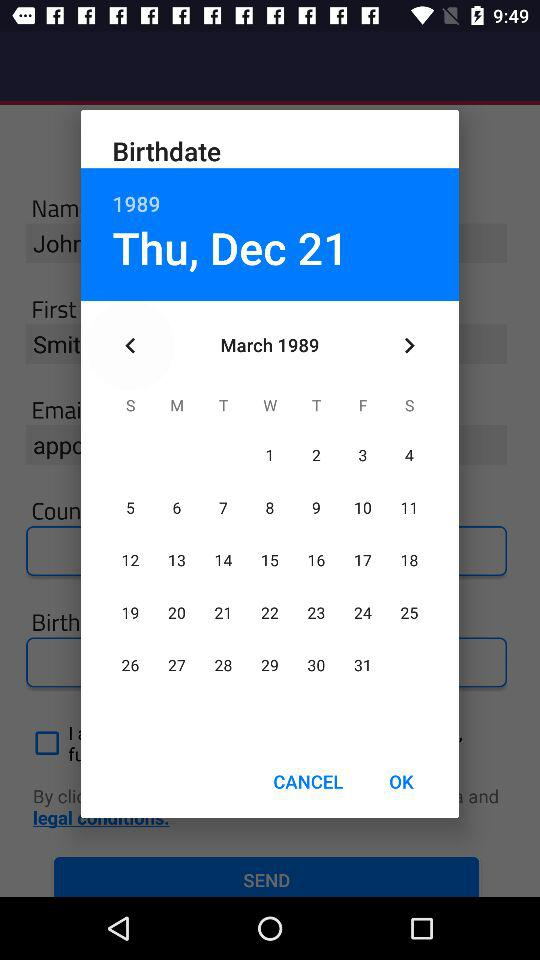What is the birthdate? The birthdate is Thursday, December 21, 1989. 